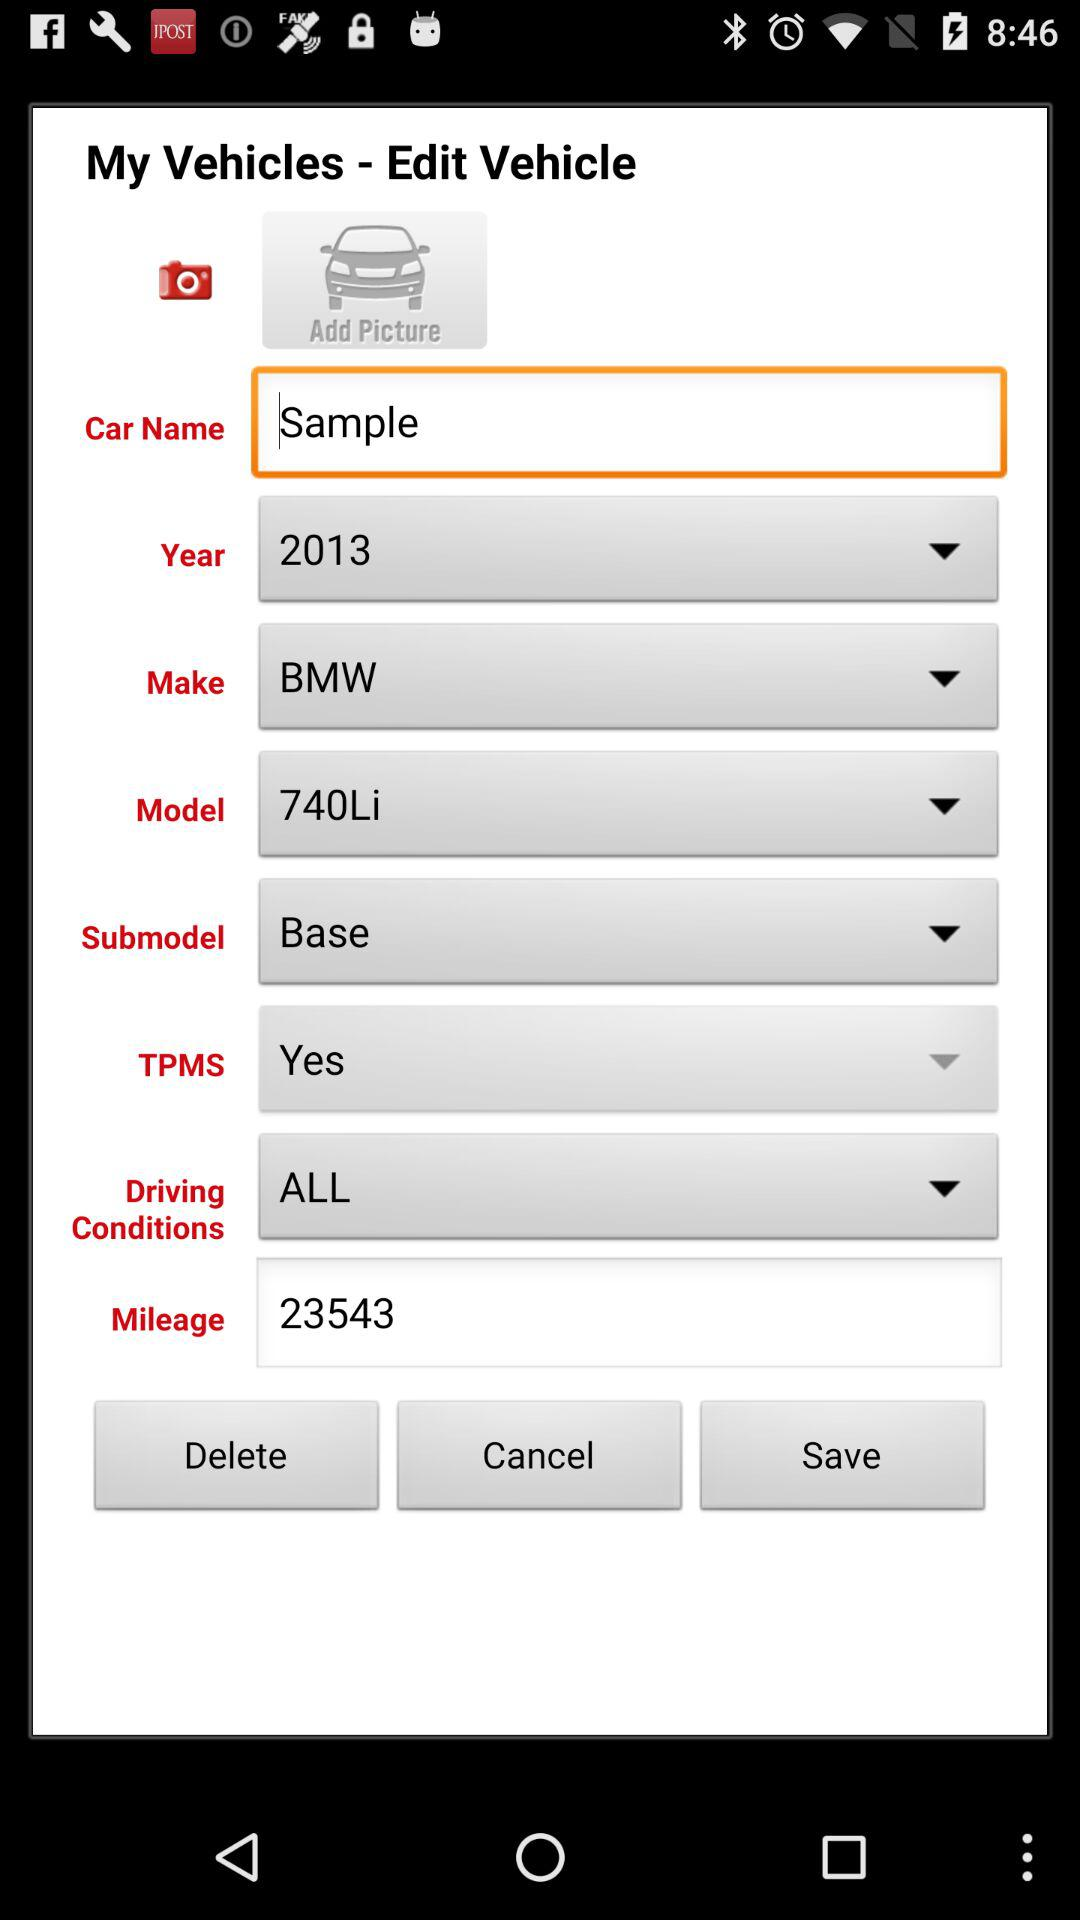What is the selected option for "Driving Conditions"? The selected option is "ALL". 